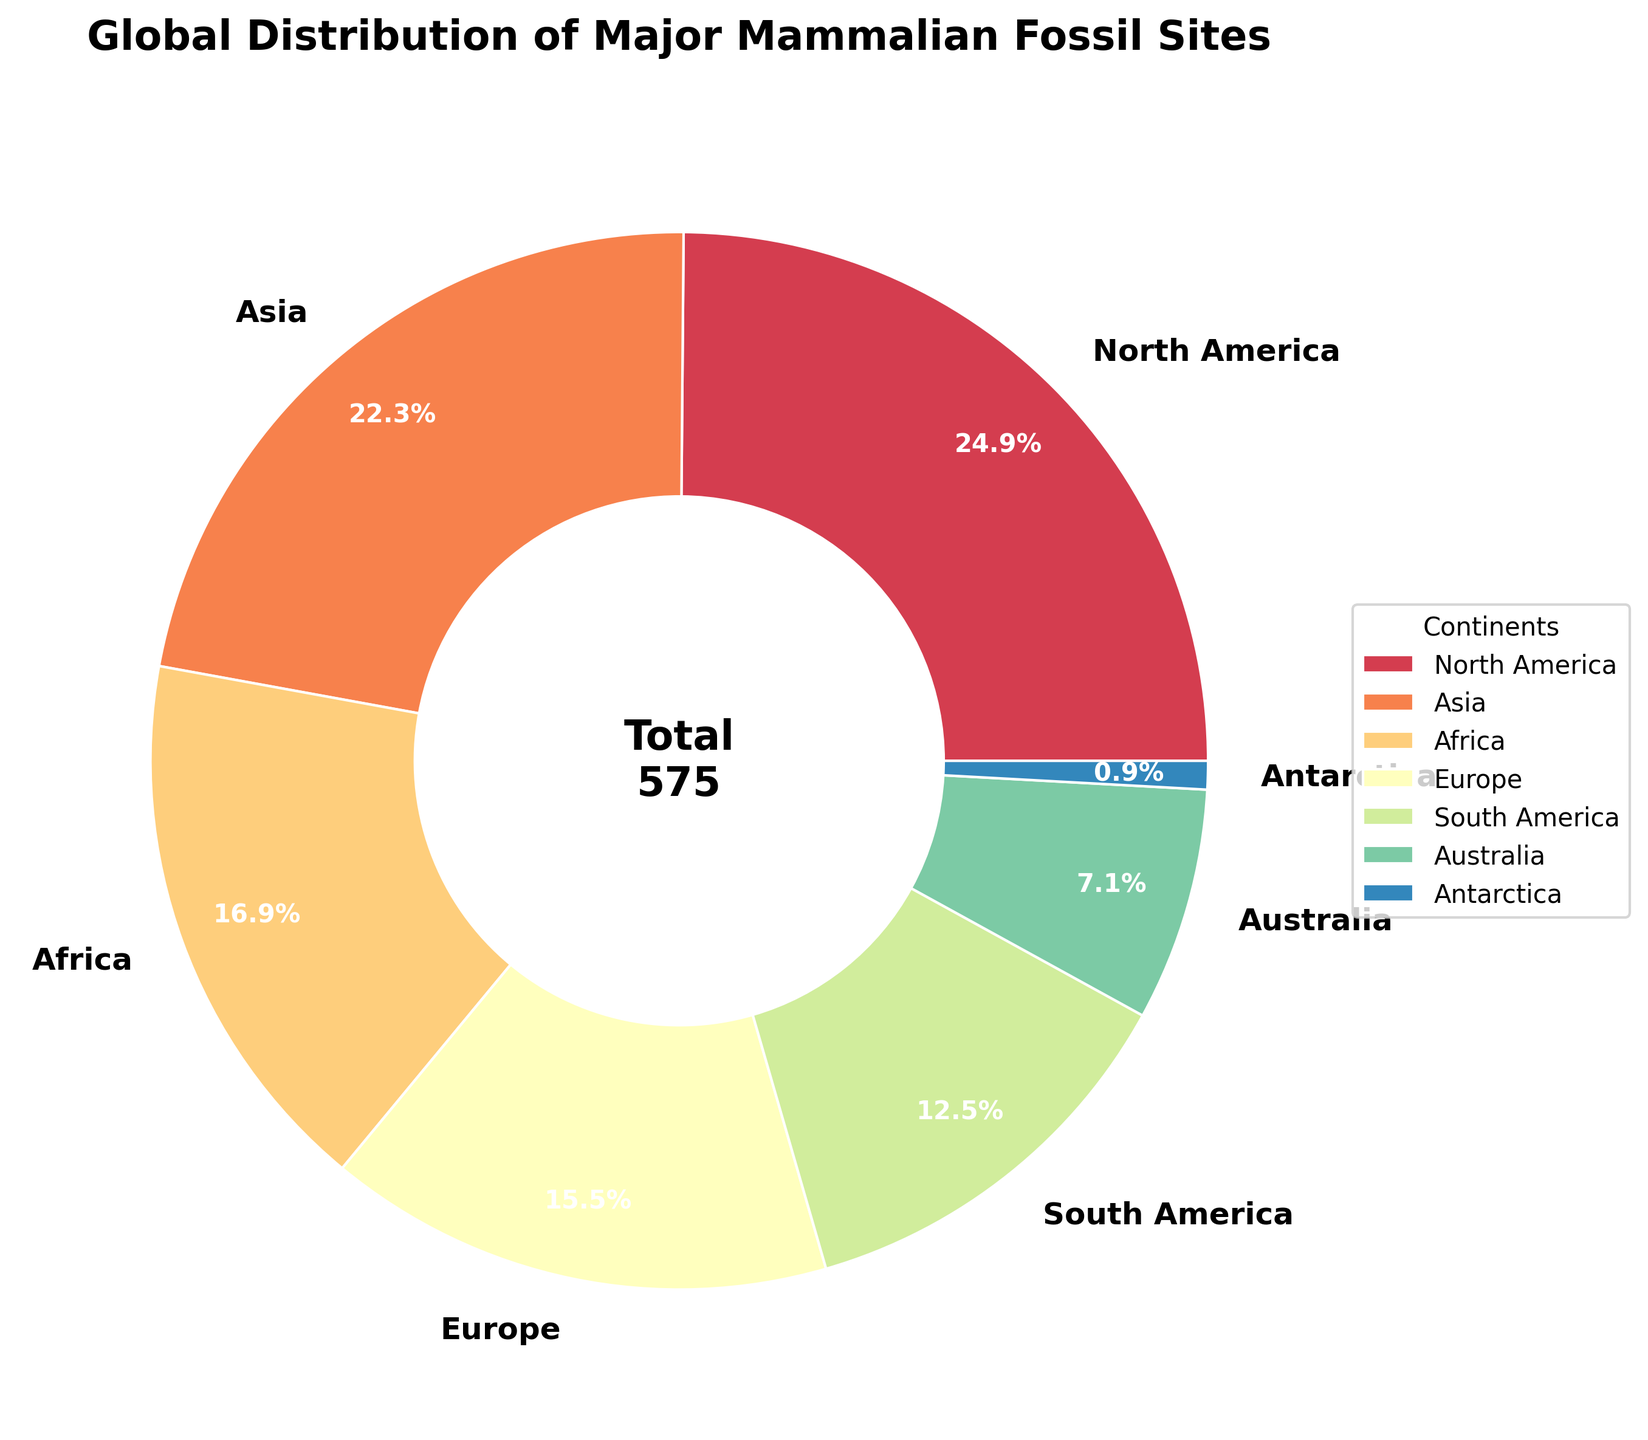What is the total number of major mammalian fossil sites across all continents? Sum the number of major mammalian fossil sites across all continents: 143 (North America) + 128 (Asia) + 97 (Africa) + 89 (Europe) + 72 (South America) + 41 (Australia) + 5 (Antarctica) = 575
Answer: 575 Which continent has the highest number of major mammalian fossil sites? Compare the number of major mammalian fossil sites for each continent. North America has 143, which is the highest among all continents
Answer: North America How much more major mammalian fossil sites does North America have compared to Antarctica? Subtract the number of major mammalian fossil sites in Antarctica from North America: 143 (North America) - 5 (Antarctica) = 138
Answer: 138 What percentage of the total major mammalian fossil sites does Asia have? Divide the number of major mammalian fossil sites in Asia by the total number of sites and multiply by 100: (128 / 575) * 100 ≈ 22.3%
Answer: 22.3% Is the number of major mammalian fossil sites in South America more or less than half of those in North America? Compare half of the number of major mammalian fossil sites in North America (143 / 2 = 71.5) with the number of sites in South America (72). South America has 72 which is slightly more than half of North America's 143
Answer: More Which continents have fewer than 50 major mammalian fossil sites? Look at the pie chart segments and identify the continents with fewer than 50 sites. Both Australia (41) and Antarctica (5) have fewer than 50 sites
Answer: Australia, Antarctica How many more major mammalian fossil sites are in Europe compared to Africa? Subtract the number of major mammalian fossil sites in Africa from Europe: 89 (Europe) - 97 (Africa) = -8 (Africa has 8 more than Europe)
Answer: -8 What is the combined percentage of major mammalian fossil sites from Europe and North America? Add the percentages of Europe and North America: Europe (15.5%) and North America (24.9%), so 15.5% + 24.9% = 40.4%
Answer: 40.4% Which three continents contribute the most to the total number of major mammalian fossil sites and what is their combined total? Identify the three continents with the highest number of fossil sites: North America (143), Asia (128), and Africa (97). Their combined total is 143 + 128 + 97 = 368
Answer: North America, Asia, Africa, 368 